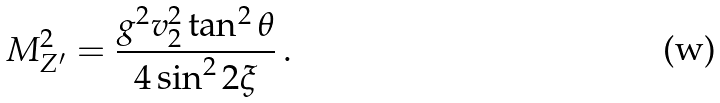<formula> <loc_0><loc_0><loc_500><loc_500>M _ { Z ^ { \prime } } ^ { 2 } = \frac { g ^ { 2 } v _ { 2 } ^ { 2 } \tan ^ { 2 } \theta } { 4 \sin ^ { 2 } 2 \xi } \, .</formula> 